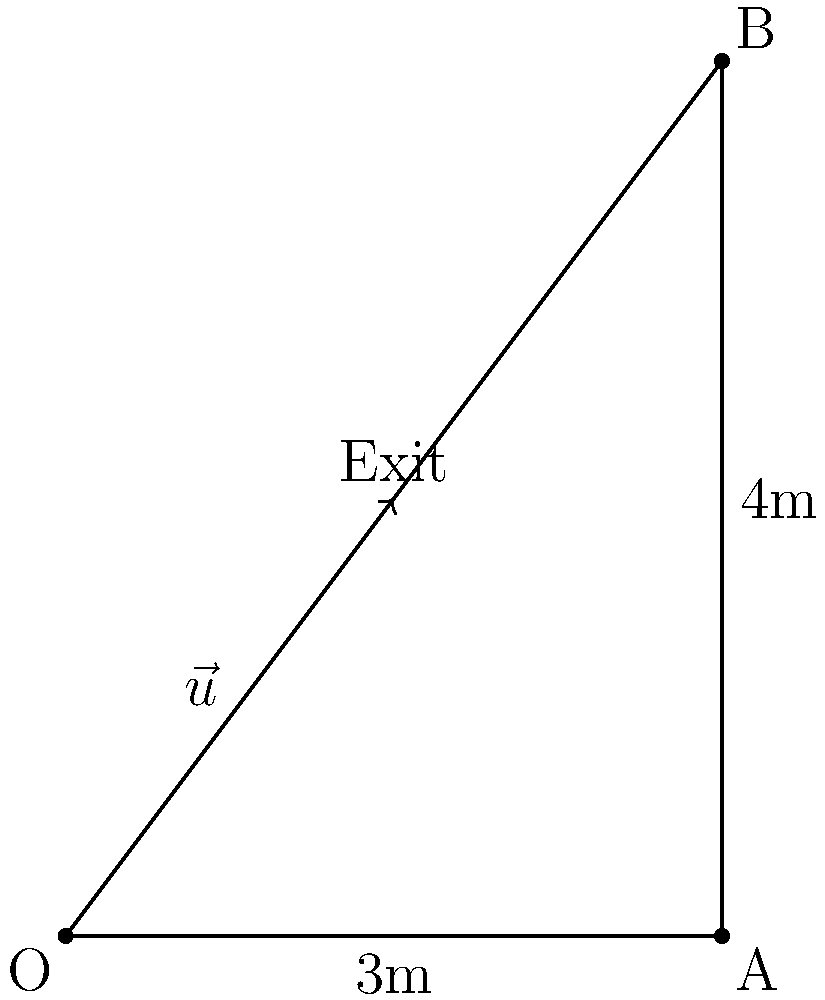During a fire drill, you need to guide your friends to the nearest emergency exit. You are at point O in a room shaped like a right triangle. The exit is located at the midpoint of the hypotenuse. If OA is 3m and AB is 4m, what is the unit vector $\vec{u}$ that points directly towards the exit? Let's approach this step-by-step:

1) First, we need to find the coordinates of point B. Since OA = 3m and AB = 4m, and the triangle is right-angled, we can conclude that B is at (3, 4).

2) The exit is at the midpoint of the hypotenuse OB. To find its coordinates:
   x-coordinate: $(0 + 3) / 2 = 1.5$
   y-coordinate: $(0 + 4) / 2 = 2$
   So, the exit is at (1.5, 2)

3) The vector from O to the exit is therefore:
   $\vec{v} = (1.5 - 0, 2 - 0) = (1.5, 2)$

4) To find the unit vector, we need to divide $\vec{v}$ by its magnitude:
   $|\vec{v}| = \sqrt{1.5^2 + 2^2} = \sqrt{2.25 + 4} = \sqrt{6.25} = 2.5$

5) The unit vector $\vec{u}$ is:
   $\vec{u} = \frac{\vec{v}}{|\vec{v}|} = (\frac{1.5}{2.5}, \frac{2}{2.5}) = (0.6, 0.8)$

Therefore, the unit vector pointing towards the exit is (0.6, 0.8).
Answer: $(0.6, 0.8)$ 